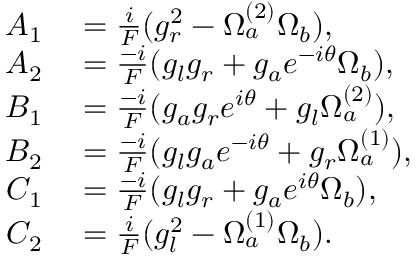Convert formula to latex. <formula><loc_0><loc_0><loc_500><loc_500>\begin{array} { r l } { A _ { 1 } } & = \frac { i } { F } ( g _ { r } ^ { 2 } - \Omega _ { a } ^ { ( 2 ) } \Omega _ { b } ) , } \\ { A _ { 2 } } & = \frac { - i } { F } ( g _ { l } g _ { r } + g _ { a } e ^ { - i \theta } \Omega _ { b } ) , } \\ { B _ { 1 } } & = \frac { - i } { F } ( g _ { a } g _ { r } e ^ { i \theta } + g _ { l } \Omega _ { a } ^ { ( 2 ) } ) , } \\ { B _ { 2 } } & = \frac { - i } { F } ( g _ { l } g _ { a } e ^ { - i \theta } + g _ { r } \Omega _ { a } ^ { ( 1 ) } ) , } \\ { C _ { 1 } } & = \frac { - i } { F } ( g _ { l } g _ { r } + g _ { a } e ^ { i \theta } \Omega _ { b } ) , } \\ { C _ { 2 } } & = \frac { i } { F } ( g _ { l } ^ { 2 } - \Omega _ { a } ^ { ( 1 ) } \Omega _ { b } ) . } \end{array}</formula> 